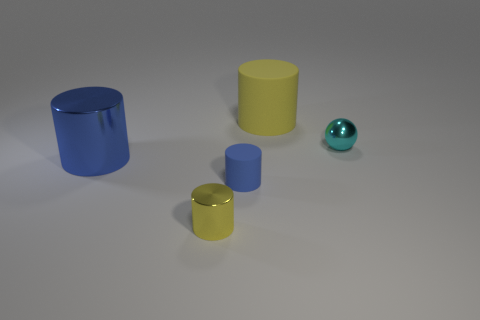Is there a pattern in the size arrangement of the objects? The objects appear to be arranged by size, with the smaller cylinders positioned in front, progressively leading to the larger cylinders positioned behind. Could the size arrangement suggest anything about their relative importance or function? While the arrangement could suggest a visual hierarchy, without additional context it is difficult to ascertain the significance or intended function. This could be an artistic display or a sizing demonstration. 